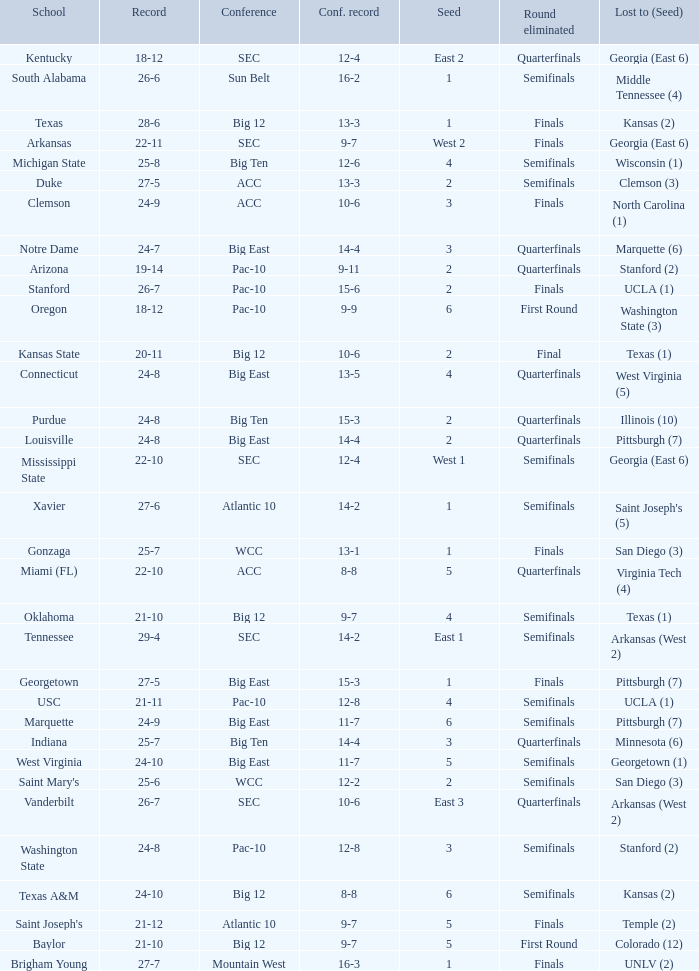Name the conference record where seed is 3 and record is 24-9 10-6. 